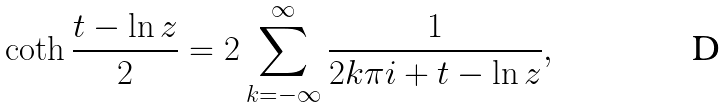Convert formula to latex. <formula><loc_0><loc_0><loc_500><loc_500>\coth { \frac { t - \ln z } { 2 } } = 2 \sum _ { k = - \infty } ^ { \infty } { \frac { 1 } { 2 k \pi i + t - \ln z } } ,</formula> 